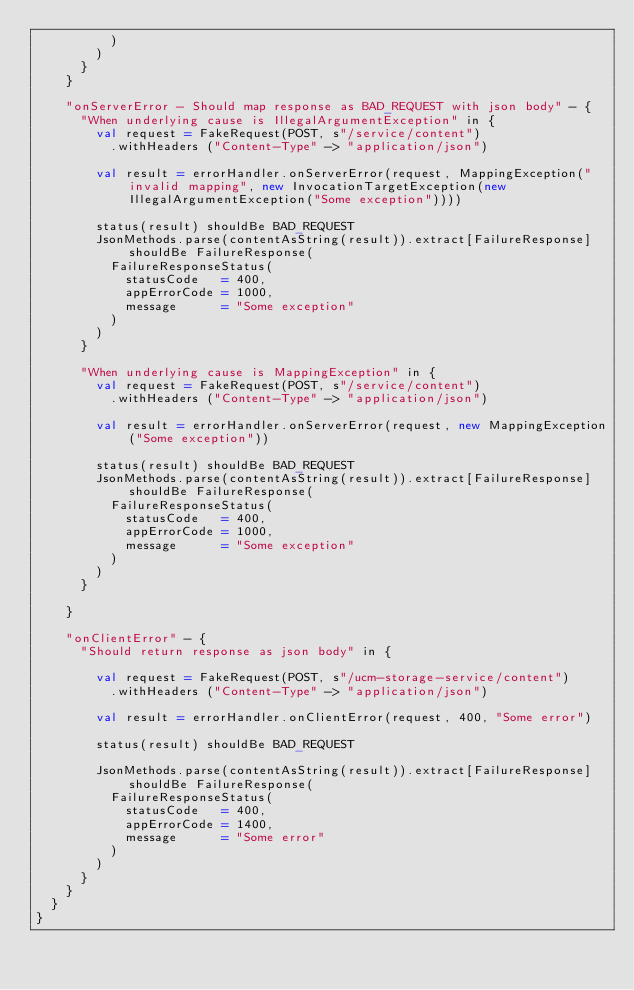<code> <loc_0><loc_0><loc_500><loc_500><_Scala_>          )
        )
      }
    }

    "onServerError - Should map response as BAD_REQUEST with json body" - {
      "When underlying cause is IllegalArgumentException" in {
        val request = FakeRequest(POST, s"/service/content")
          .withHeaders ("Content-Type" -> "application/json")

        val result = errorHandler.onServerError(request, MappingException("invalid mapping", new InvocationTargetException(new IllegalArgumentException("Some exception"))))

        status(result) shouldBe BAD_REQUEST
        JsonMethods.parse(contentAsString(result)).extract[FailureResponse] shouldBe FailureResponse(
          FailureResponseStatus(
            statusCode   = 400,
            appErrorCode = 1000,
            message      = "Some exception"
          )
        )
      }

      "When underlying cause is MappingException" in {
        val request = FakeRequest(POST, s"/service/content")
          .withHeaders ("Content-Type" -> "application/json")

        val result = errorHandler.onServerError(request, new MappingException("Some exception"))

        status(result) shouldBe BAD_REQUEST
        JsonMethods.parse(contentAsString(result)).extract[FailureResponse] shouldBe FailureResponse(
          FailureResponseStatus(
            statusCode   = 400,
            appErrorCode = 1000,
            message      = "Some exception"
          )
        )
      }

    }

    "onClientError" - {
      "Should return response as json body" in {

        val request = FakeRequest(POST, s"/ucm-storage-service/content")
          .withHeaders ("Content-Type" -> "application/json")

        val result = errorHandler.onClientError(request, 400, "Some error")

        status(result) shouldBe BAD_REQUEST

        JsonMethods.parse(contentAsString(result)).extract[FailureResponse] shouldBe FailureResponse(
          FailureResponseStatus(
            statusCode   = 400,
            appErrorCode = 1400,
            message      = "Some error"
          )
        )
      }
    }
  }
}
</code> 